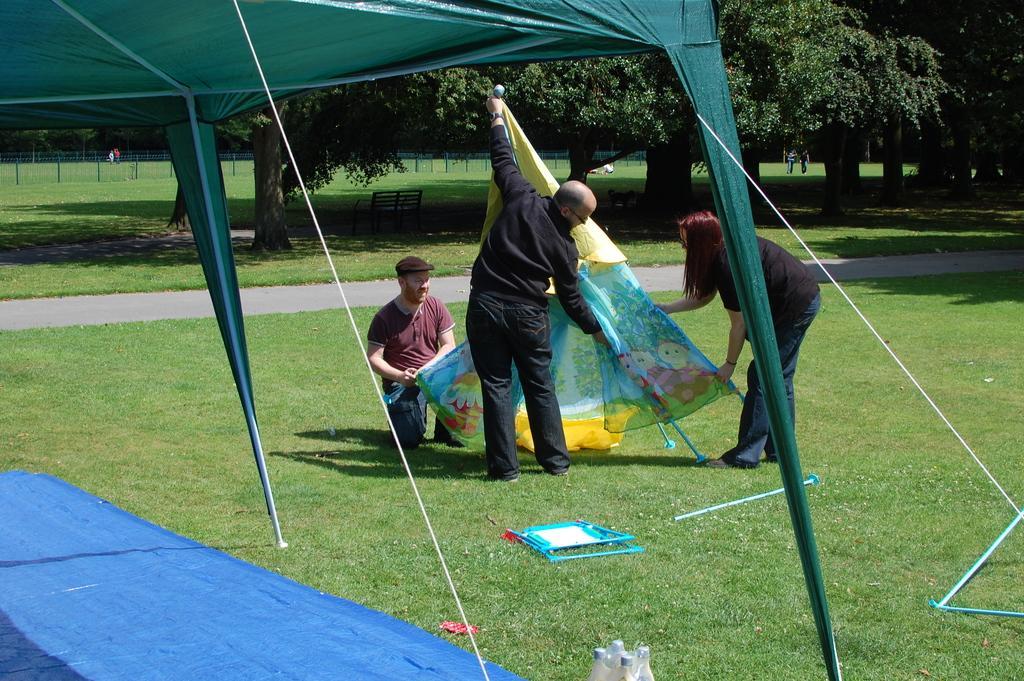Can you describe this image briefly? In the image we can see the tent and blue cover on the ground and in the middle of the ground there are three people holding an object. In the background there are trees, fence and also there is a bench. We can even see grass. 